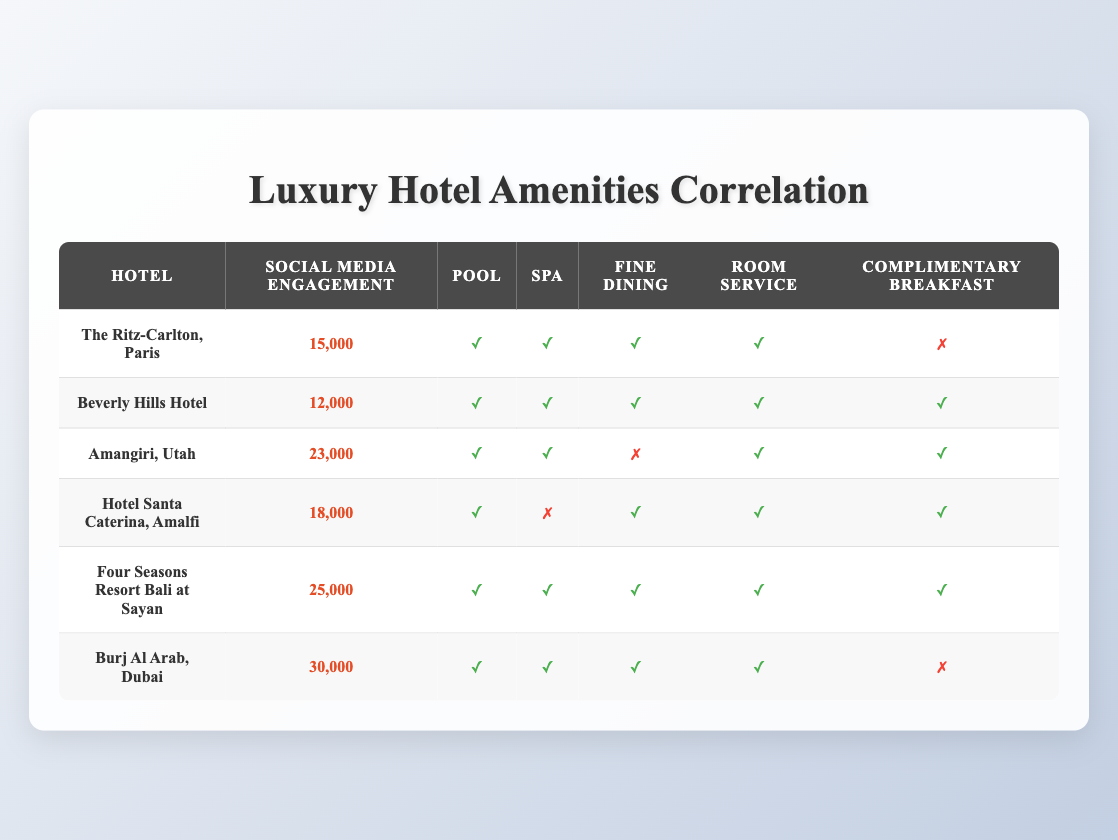What is the hotel with the highest social media engagement? By looking at the "Social Media Engagement" column, we can see that "Burj Al Arab, Dubai" has the highest engagement score at 30,000.
Answer: Burj Al Arab, Dubai How many hotels offer a spa? We can count the rows where the "Spa" column has a checkmark. In total, four hotels (The Ritz-Carlton, Beverly Hills Hotel, Amangiri, and Burj Al Arab) offer a spa.
Answer: 4 What is the average social media engagement for hotels offering complimentary breakfast? The hotels that offer complimentary breakfast are Beverly Hills Hotel, Amangiri, Hotel Santa Caterina, and Four Seasons Resort. Their engagement scores are 12,000, 23,000, 18,000, and 25,000 respectively. The sum is (12,000 + 23,000 + 18,000 + 25,000) = 78,000. There are 4 hotels, thus, the average is 78,000 / 4 = 19,500.
Answer: 19,500 Is there a hotel that offers fine dining but does not have a spa? Looking at the table, we note that "Hotel Santa Caterina, Amalfi" offers fine dining (checkmark) but does not have a spa (cross mark). Therefore, the answer is yes.
Answer: Yes What is the total social media engagement of hotels with room service? All hotels in the table offer room service, so we can sum the social media engagements: 15,000 + 12,000 + 23,000 + 18,000 + 25,000 + 30,000 = 123,000.
Answer: 123,000 How many hotels have both a pool and fine dining? The hotels that have both amenities are The Ritz-Carlton, Beverly Hills Hotel, Amangiri, Hotel Santa Caterina, Four Seasons Resort, and Burj Al Arab. Counting them, we find a total of 6 hotels.
Answer: 6 Does the hotel with the least engagement offer a pool? The hotel with the least social media engagement is "Beverly Hills Hotel" with 12,000, and it does offer a pool (checkmark). Therefore, the answer is yes.
Answer: Yes Which hotel has more social media engagement: Amangiri, Utah or Hotel Santa Caterina, Amalfi? Amangiri, Utah has an engagement score of 23,000, whereas Hotel Santa Caterina, Amalfi has an engagement score of 18,000. Therefore, Amangiri has more engagement.
Answer: Amangiri, Utah 